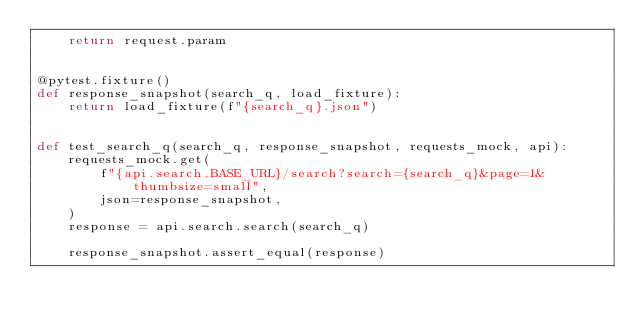<code> <loc_0><loc_0><loc_500><loc_500><_Python_>    return request.param


@pytest.fixture()
def response_snapshot(search_q, load_fixture):
    return load_fixture(f"{search_q}.json")


def test_search_q(search_q, response_snapshot, requests_mock, api):
    requests_mock.get(
        f"{api.search.BASE_URL}/search?search={search_q}&page=1&thumbsize=small",
        json=response_snapshot,
    )
    response = api.search.search(search_q)

    response_snapshot.assert_equal(response)
</code> 